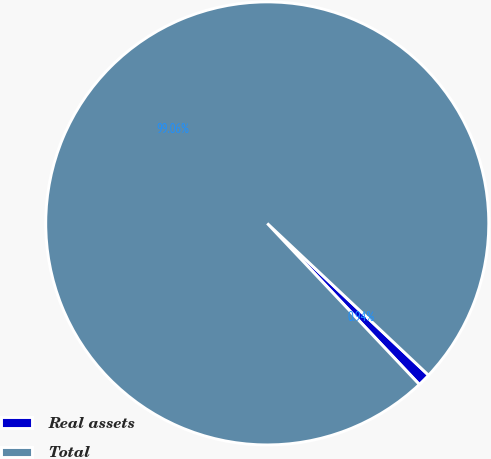<chart> <loc_0><loc_0><loc_500><loc_500><pie_chart><fcel>Real assets<fcel>Total<nl><fcel>0.94%<fcel>99.06%<nl></chart> 